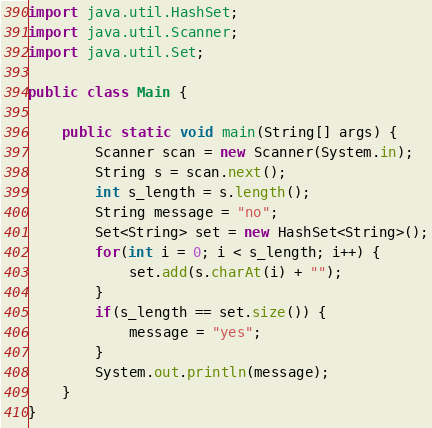Convert code to text. <code><loc_0><loc_0><loc_500><loc_500><_Java_>import java.util.HashSet;
import java.util.Scanner;
import java.util.Set;

public class Main {

	public static void main(String[] args) {
		Scanner scan = new Scanner(System.in);
		String s = scan.next();
		int s_length = s.length();
		String message = "no";
		Set<String> set = new HashSet<String>();
		for(int i = 0; i < s_length; i++) {
			set.add(s.charAt(i) + "");
		}
		if(s_length == set.size()) {
			message = "yes";
		}
		System.out.println(message);
	}
}</code> 